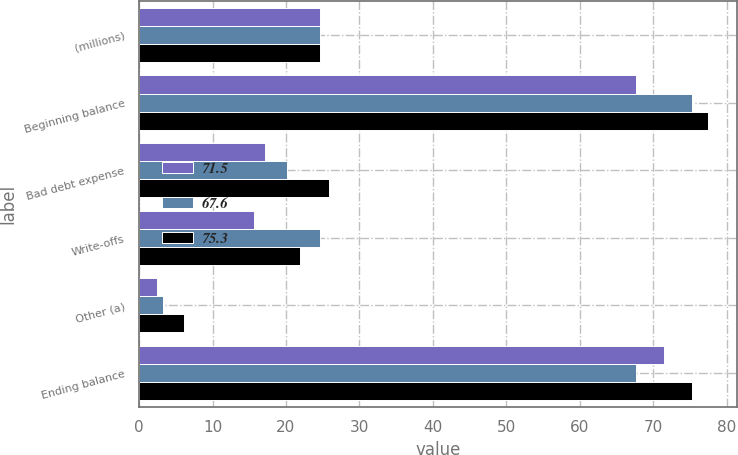Convert chart. <chart><loc_0><loc_0><loc_500><loc_500><stacked_bar_chart><ecel><fcel>(millions)<fcel>Beginning balance<fcel>Bad debt expense<fcel>Write-offs<fcel>Other (a)<fcel>Ending balance<nl><fcel>71.5<fcel>24.6<fcel>67.6<fcel>17.1<fcel>15.7<fcel>2.5<fcel>71.5<nl><fcel>67.6<fcel>24.6<fcel>75.3<fcel>20.1<fcel>24.6<fcel>3.2<fcel>67.6<nl><fcel>75.3<fcel>24.6<fcel>77.5<fcel>25.8<fcel>21.9<fcel>6.1<fcel>75.3<nl></chart> 